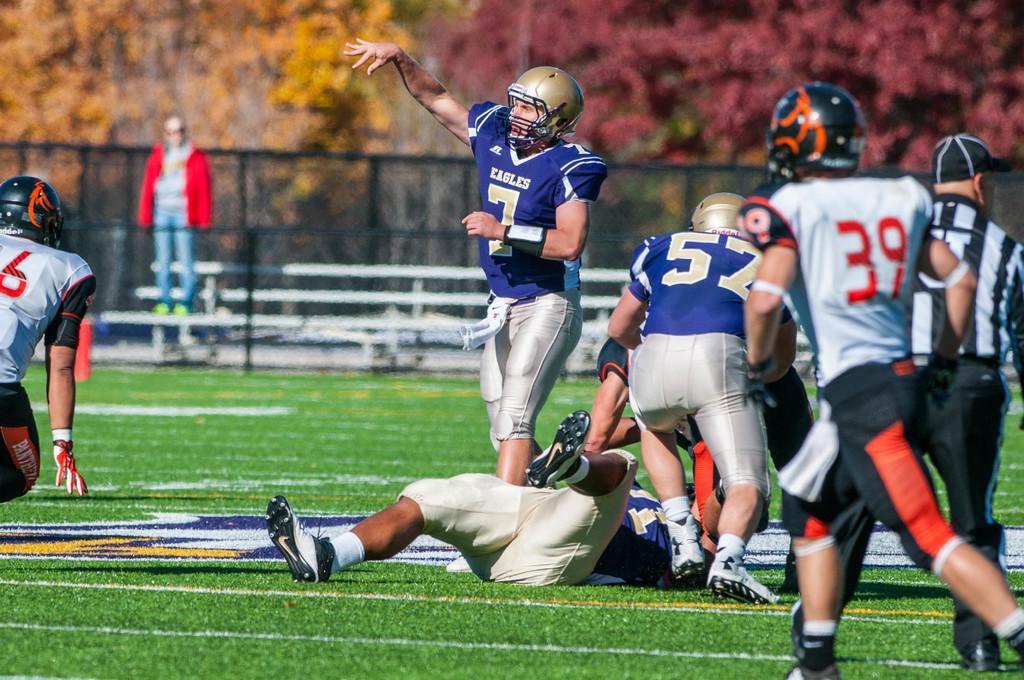Could you give a brief overview of what you see in this image? The picture is taken in a american football. On the right side there are players playing game. On the left there is a person running. In the foreground there is grass. The background is blurred. In the background there are trees, fencing and benches. 